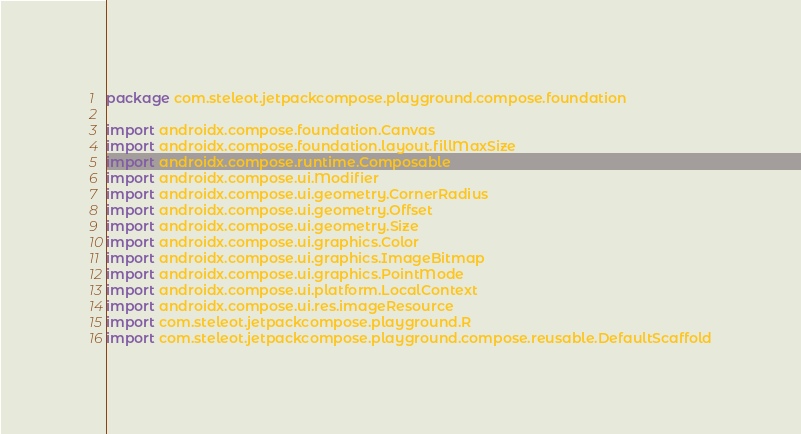Convert code to text. <code><loc_0><loc_0><loc_500><loc_500><_Kotlin_>package com.steleot.jetpackcompose.playground.compose.foundation

import androidx.compose.foundation.Canvas
import androidx.compose.foundation.layout.fillMaxSize
import androidx.compose.runtime.Composable
import androidx.compose.ui.Modifier
import androidx.compose.ui.geometry.CornerRadius
import androidx.compose.ui.geometry.Offset
import androidx.compose.ui.geometry.Size
import androidx.compose.ui.graphics.Color
import androidx.compose.ui.graphics.ImageBitmap
import androidx.compose.ui.graphics.PointMode
import androidx.compose.ui.platform.LocalContext
import androidx.compose.ui.res.imageResource
import com.steleot.jetpackcompose.playground.R
import com.steleot.jetpackcompose.playground.compose.reusable.DefaultScaffold</code> 